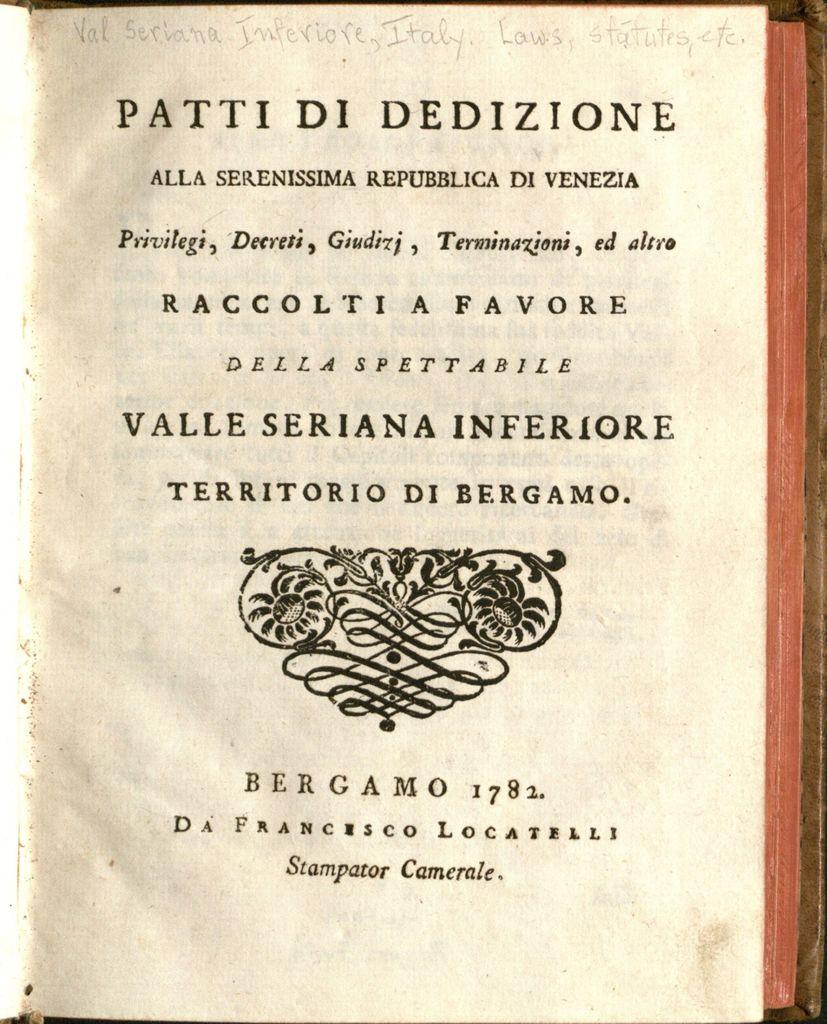What is the title of the book?
Make the answer very short. Patti di dedizione. What is the year of the text?
Keep it short and to the point. 1782. 